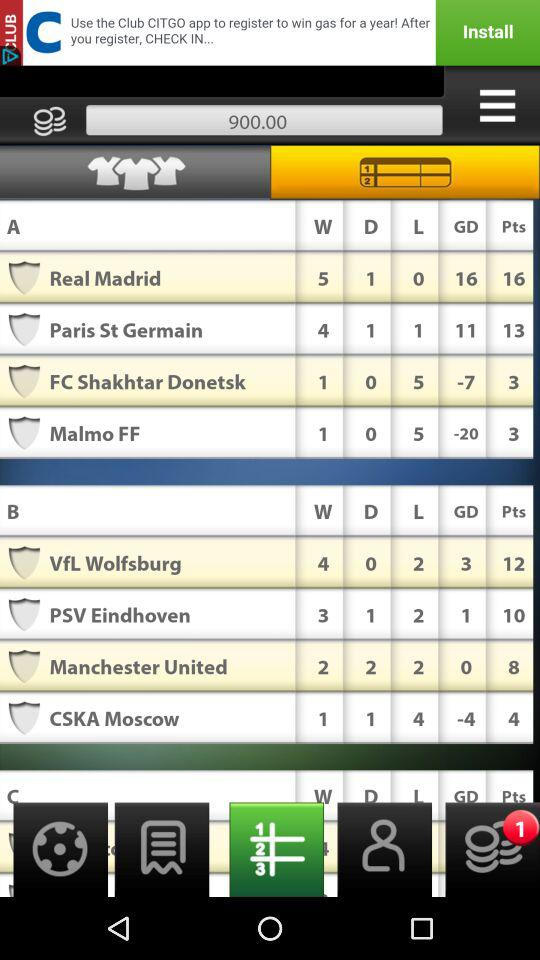How many GD points does "Malmo FF" have? "Malmo FF" has -20 GD points. 